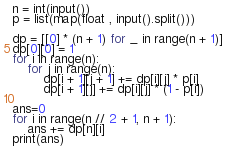<code> <loc_0><loc_0><loc_500><loc_500><_Python_>n = int(input())
p = list(map(float , input().split()))

dp = [[0] * (n + 1) for _ in range(n + 1)]
dp[0][0] = 1
for i in range(n):
    for j in range(n):
        dp[i + 1][j + 1] += dp[i][j] * p[i]
        dp[i + 1][j] += dp[i][j] * (1 - p[i])

ans=0
for i in range(n // 2 + 1, n + 1):
    ans += dp[n][i]
print(ans)</code> 